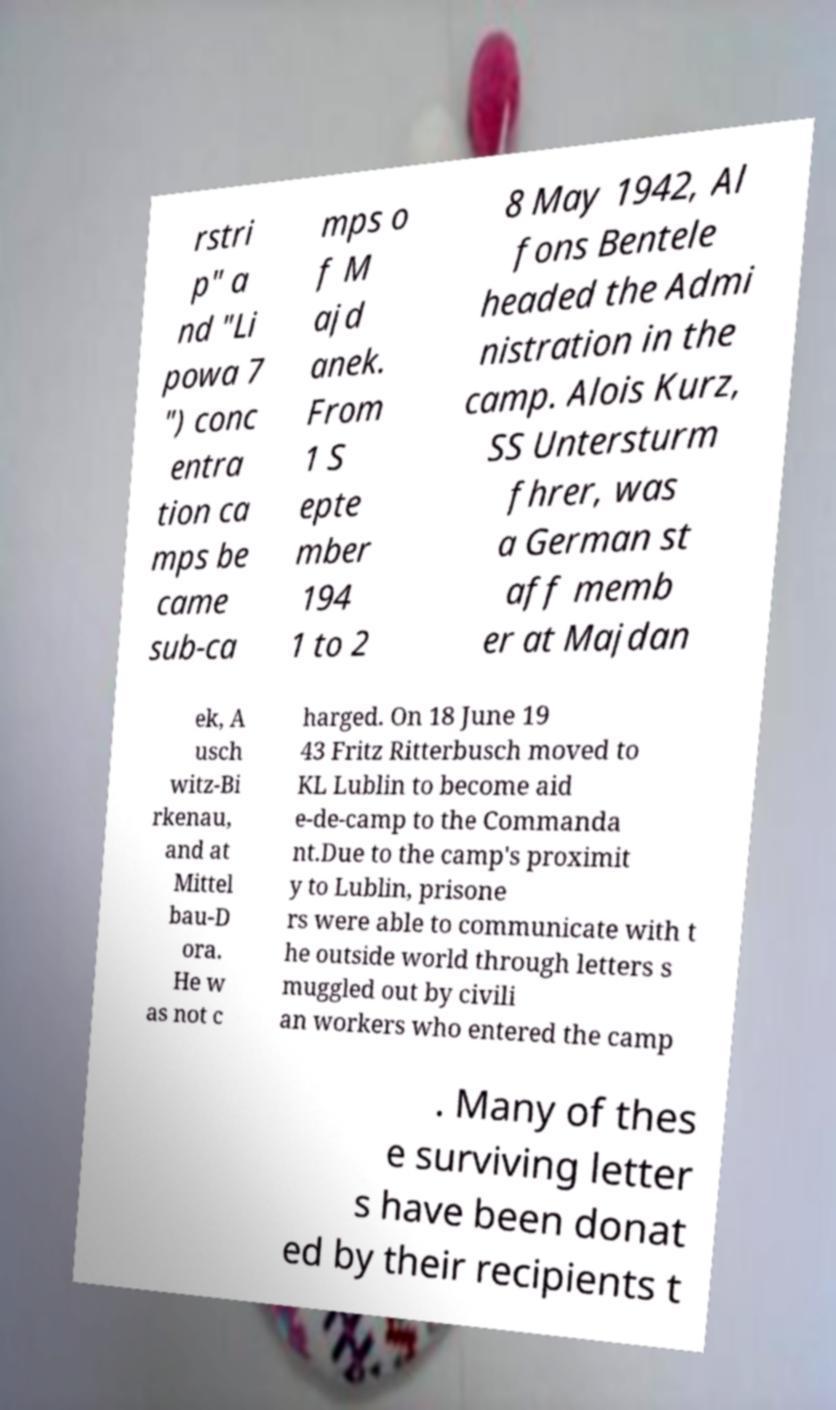Could you extract and type out the text from this image? rstri p" a nd "Li powa 7 ") conc entra tion ca mps be came sub-ca mps o f M ajd anek. From 1 S epte mber 194 1 to 2 8 May 1942, Al fons Bentele headed the Admi nistration in the camp. Alois Kurz, SS Untersturm fhrer, was a German st aff memb er at Majdan ek, A usch witz-Bi rkenau, and at Mittel bau-D ora. He w as not c harged. On 18 June 19 43 Fritz Ritterbusch moved to KL Lublin to become aid e-de-camp to the Commanda nt.Due to the camp's proximit y to Lublin, prisone rs were able to communicate with t he outside world through letters s muggled out by civili an workers who entered the camp . Many of thes e surviving letter s have been donat ed by their recipients t 